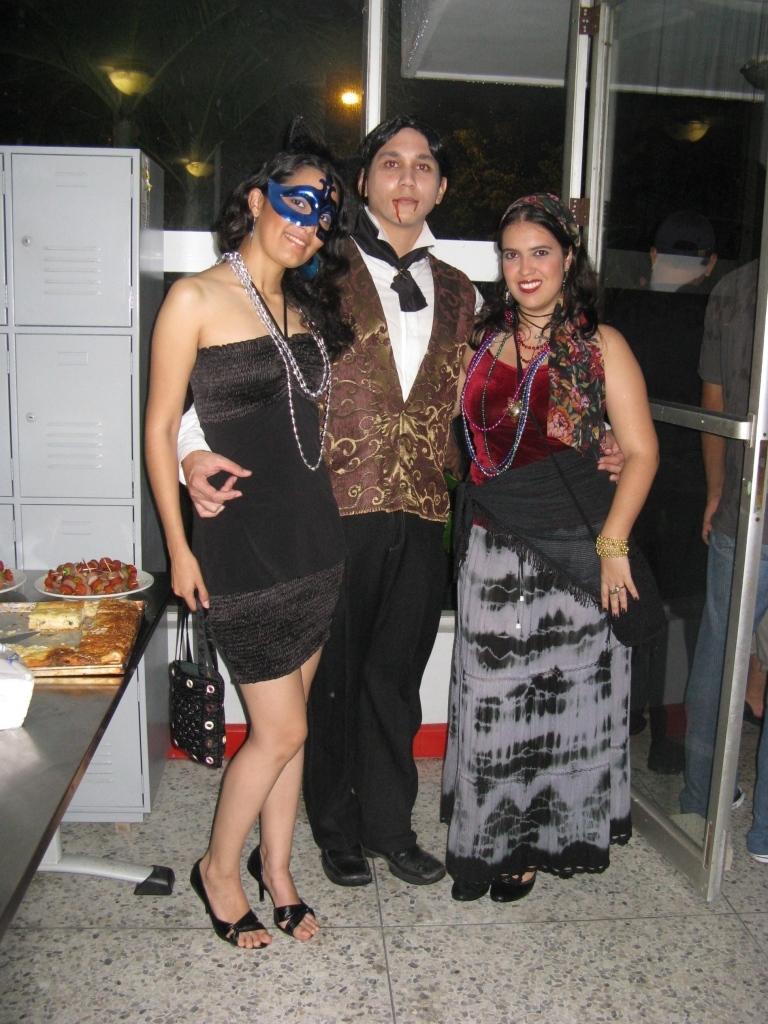Please provide a concise description of this image. This picture shows few people standing a man and couple of women and they wore ornaments on their neck and we see a woman holding a handbag and we see food in the plates and napkins on the table and we see a locker box on the side and a woman wore mask on the face. 